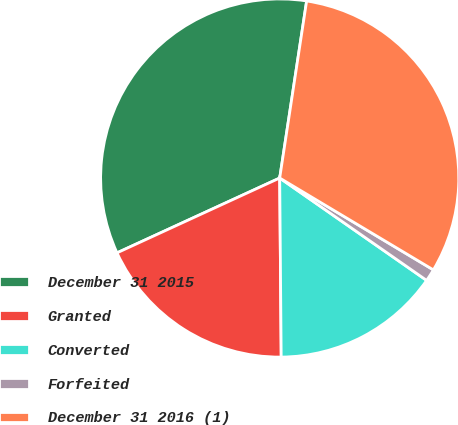<chart> <loc_0><loc_0><loc_500><loc_500><pie_chart><fcel>December 31 2015<fcel>Granted<fcel>Converted<fcel>Forfeited<fcel>December 31 2016 (1)<nl><fcel>34.26%<fcel>18.27%<fcel>15.18%<fcel>1.11%<fcel>31.17%<nl></chart> 